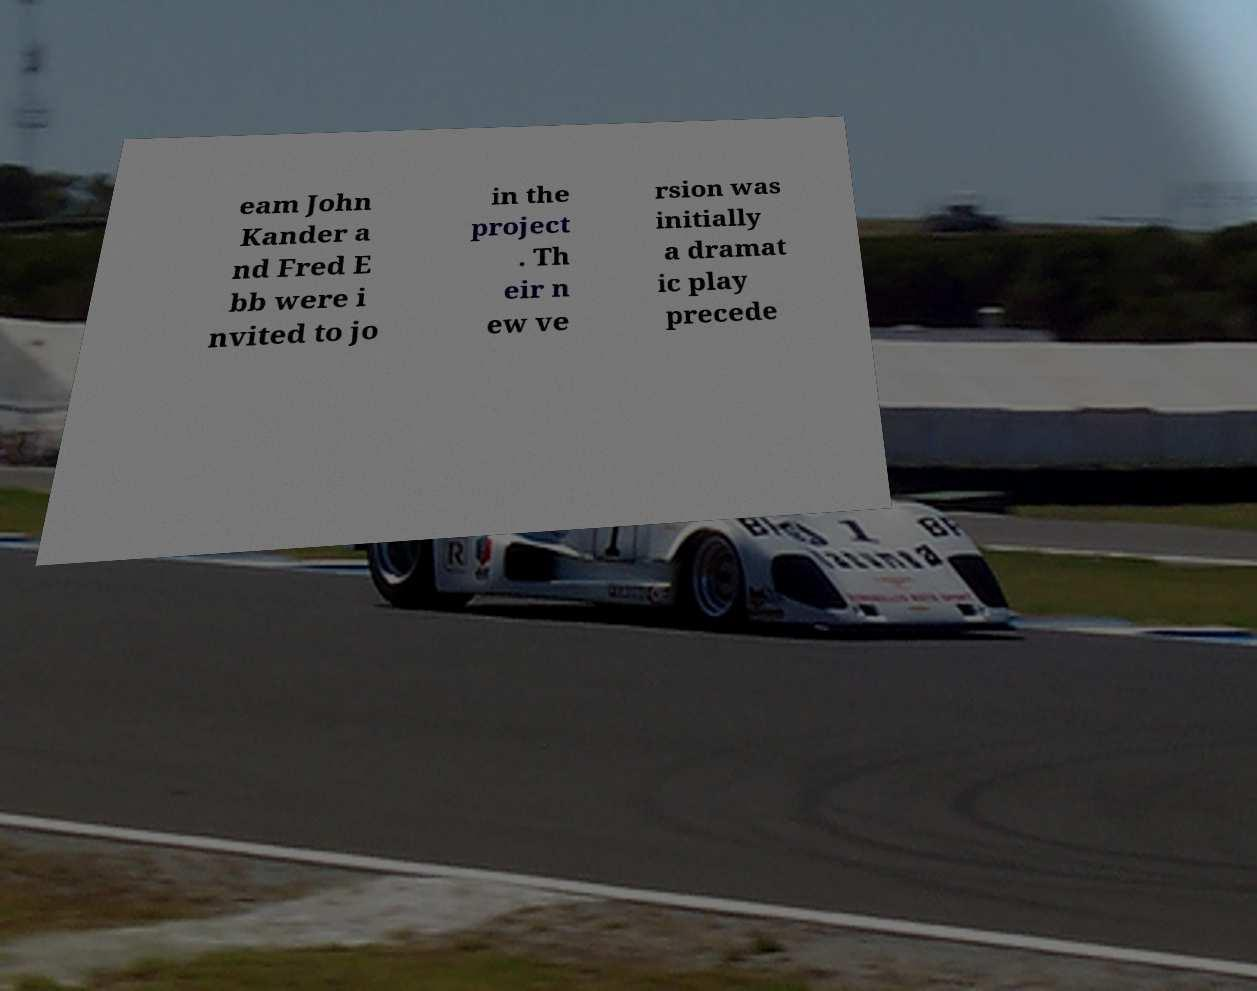Please identify and transcribe the text found in this image. eam John Kander a nd Fred E bb were i nvited to jo in the project . Th eir n ew ve rsion was initially a dramat ic play precede 